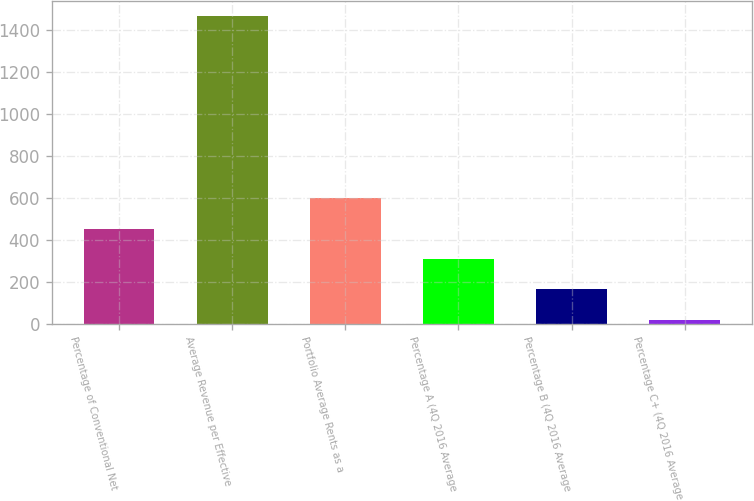<chart> <loc_0><loc_0><loc_500><loc_500><bar_chart><fcel>Percentage of Conventional Net<fcel>Average Revenue per Effective<fcel>Portfolio Average Rents as a<fcel>Percentage A (4Q 2016 Average<fcel>Percentage B (4Q 2016 Average<fcel>Percentage C+ (4Q 2016 Average<nl><fcel>453.3<fcel>1469<fcel>598.4<fcel>308.2<fcel>163.1<fcel>18<nl></chart> 